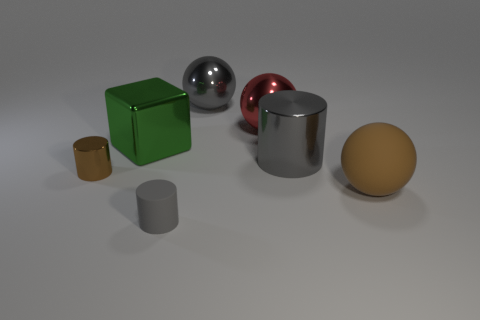Subtract all small cylinders. How many cylinders are left? 1 Add 1 gray matte objects. How many objects exist? 8 Subtract all blocks. How many objects are left? 6 Subtract all brown spheres. Subtract all blue cylinders. How many spheres are left? 2 Subtract all green spheres. How many green cylinders are left? 0 Subtract all brown rubber objects. Subtract all green metallic cubes. How many objects are left? 5 Add 3 gray cylinders. How many gray cylinders are left? 5 Add 4 big gray metal things. How many big gray metal things exist? 6 Subtract all brown cylinders. How many cylinders are left? 2 Subtract 0 yellow cylinders. How many objects are left? 7 